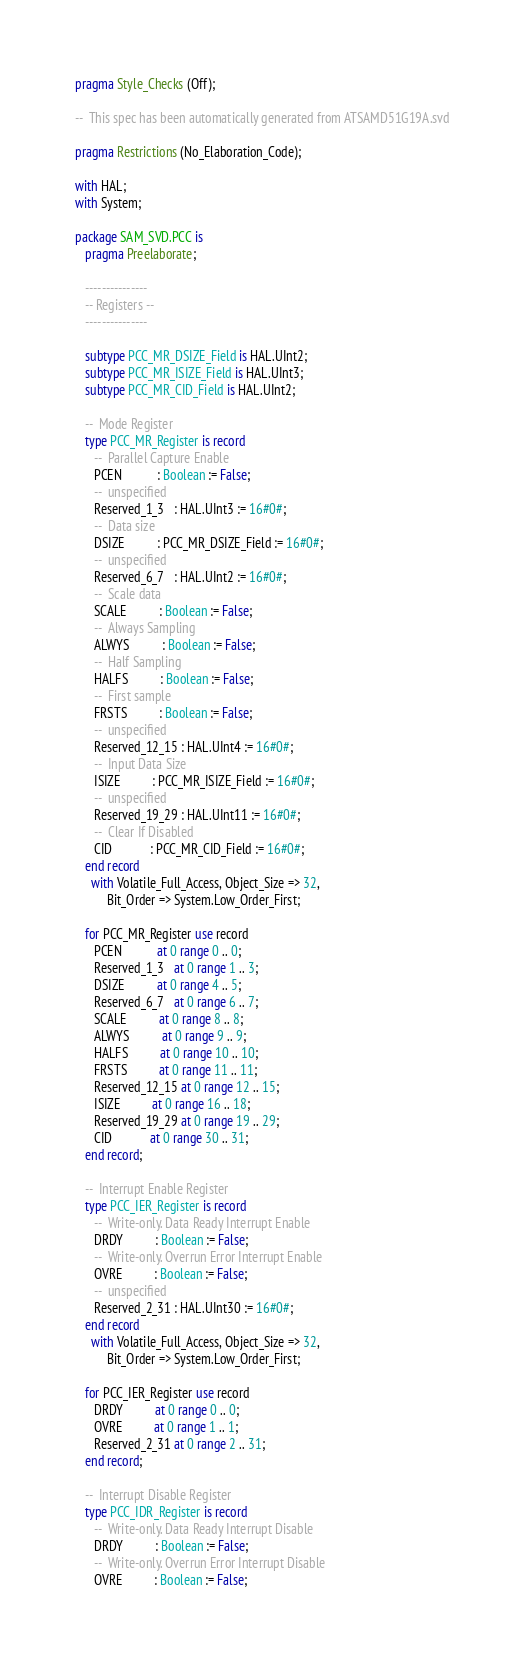<code> <loc_0><loc_0><loc_500><loc_500><_Ada_>pragma Style_Checks (Off);

--  This spec has been automatically generated from ATSAMD51G19A.svd

pragma Restrictions (No_Elaboration_Code);

with HAL;
with System;

package SAM_SVD.PCC is
   pragma Preelaborate;

   ---------------
   -- Registers --
   ---------------

   subtype PCC_MR_DSIZE_Field is HAL.UInt2;
   subtype PCC_MR_ISIZE_Field is HAL.UInt3;
   subtype PCC_MR_CID_Field is HAL.UInt2;

   --  Mode Register
   type PCC_MR_Register is record
      --  Parallel Capture Enable
      PCEN           : Boolean := False;
      --  unspecified
      Reserved_1_3   : HAL.UInt3 := 16#0#;
      --  Data size
      DSIZE          : PCC_MR_DSIZE_Field := 16#0#;
      --  unspecified
      Reserved_6_7   : HAL.UInt2 := 16#0#;
      --  Scale data
      SCALE          : Boolean := False;
      --  Always Sampling
      ALWYS          : Boolean := False;
      --  Half Sampling
      HALFS          : Boolean := False;
      --  First sample
      FRSTS          : Boolean := False;
      --  unspecified
      Reserved_12_15 : HAL.UInt4 := 16#0#;
      --  Input Data Size
      ISIZE          : PCC_MR_ISIZE_Field := 16#0#;
      --  unspecified
      Reserved_19_29 : HAL.UInt11 := 16#0#;
      --  Clear If Disabled
      CID            : PCC_MR_CID_Field := 16#0#;
   end record
     with Volatile_Full_Access, Object_Size => 32,
          Bit_Order => System.Low_Order_First;

   for PCC_MR_Register use record
      PCEN           at 0 range 0 .. 0;
      Reserved_1_3   at 0 range 1 .. 3;
      DSIZE          at 0 range 4 .. 5;
      Reserved_6_7   at 0 range 6 .. 7;
      SCALE          at 0 range 8 .. 8;
      ALWYS          at 0 range 9 .. 9;
      HALFS          at 0 range 10 .. 10;
      FRSTS          at 0 range 11 .. 11;
      Reserved_12_15 at 0 range 12 .. 15;
      ISIZE          at 0 range 16 .. 18;
      Reserved_19_29 at 0 range 19 .. 29;
      CID            at 0 range 30 .. 31;
   end record;

   --  Interrupt Enable Register
   type PCC_IER_Register is record
      --  Write-only. Data Ready Interrupt Enable
      DRDY          : Boolean := False;
      --  Write-only. Overrun Error Interrupt Enable
      OVRE          : Boolean := False;
      --  unspecified
      Reserved_2_31 : HAL.UInt30 := 16#0#;
   end record
     with Volatile_Full_Access, Object_Size => 32,
          Bit_Order => System.Low_Order_First;

   for PCC_IER_Register use record
      DRDY          at 0 range 0 .. 0;
      OVRE          at 0 range 1 .. 1;
      Reserved_2_31 at 0 range 2 .. 31;
   end record;

   --  Interrupt Disable Register
   type PCC_IDR_Register is record
      --  Write-only. Data Ready Interrupt Disable
      DRDY          : Boolean := False;
      --  Write-only. Overrun Error Interrupt Disable
      OVRE          : Boolean := False;</code> 